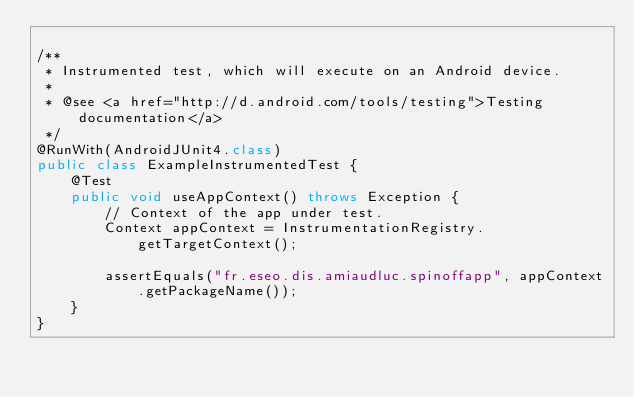Convert code to text. <code><loc_0><loc_0><loc_500><loc_500><_Java_>
/**
 * Instrumented test, which will execute on an Android device.
 *
 * @see <a href="http://d.android.com/tools/testing">Testing documentation</a>
 */
@RunWith(AndroidJUnit4.class)
public class ExampleInstrumentedTest {
    @Test
    public void useAppContext() throws Exception {
        // Context of the app under test.
        Context appContext = InstrumentationRegistry.getTargetContext();

        assertEquals("fr.eseo.dis.amiaudluc.spinoffapp", appContext.getPackageName());
    }
}
</code> 